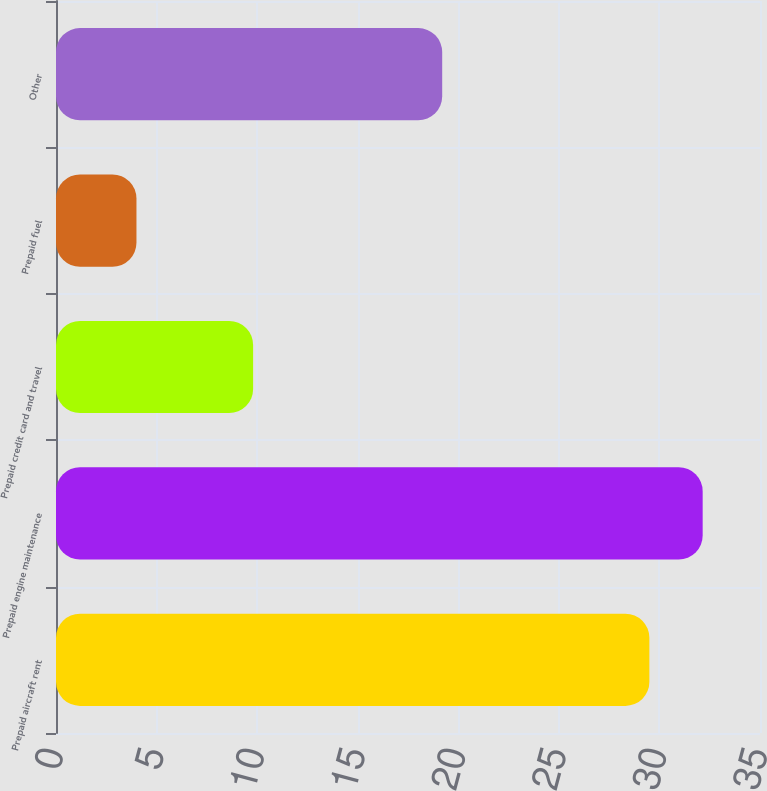<chart> <loc_0><loc_0><loc_500><loc_500><bar_chart><fcel>Prepaid aircraft rent<fcel>Prepaid engine maintenance<fcel>Prepaid credit card and travel<fcel>Prepaid fuel<fcel>Other<nl><fcel>29.5<fcel>32.15<fcel>9.8<fcel>4<fcel>19.2<nl></chart> 